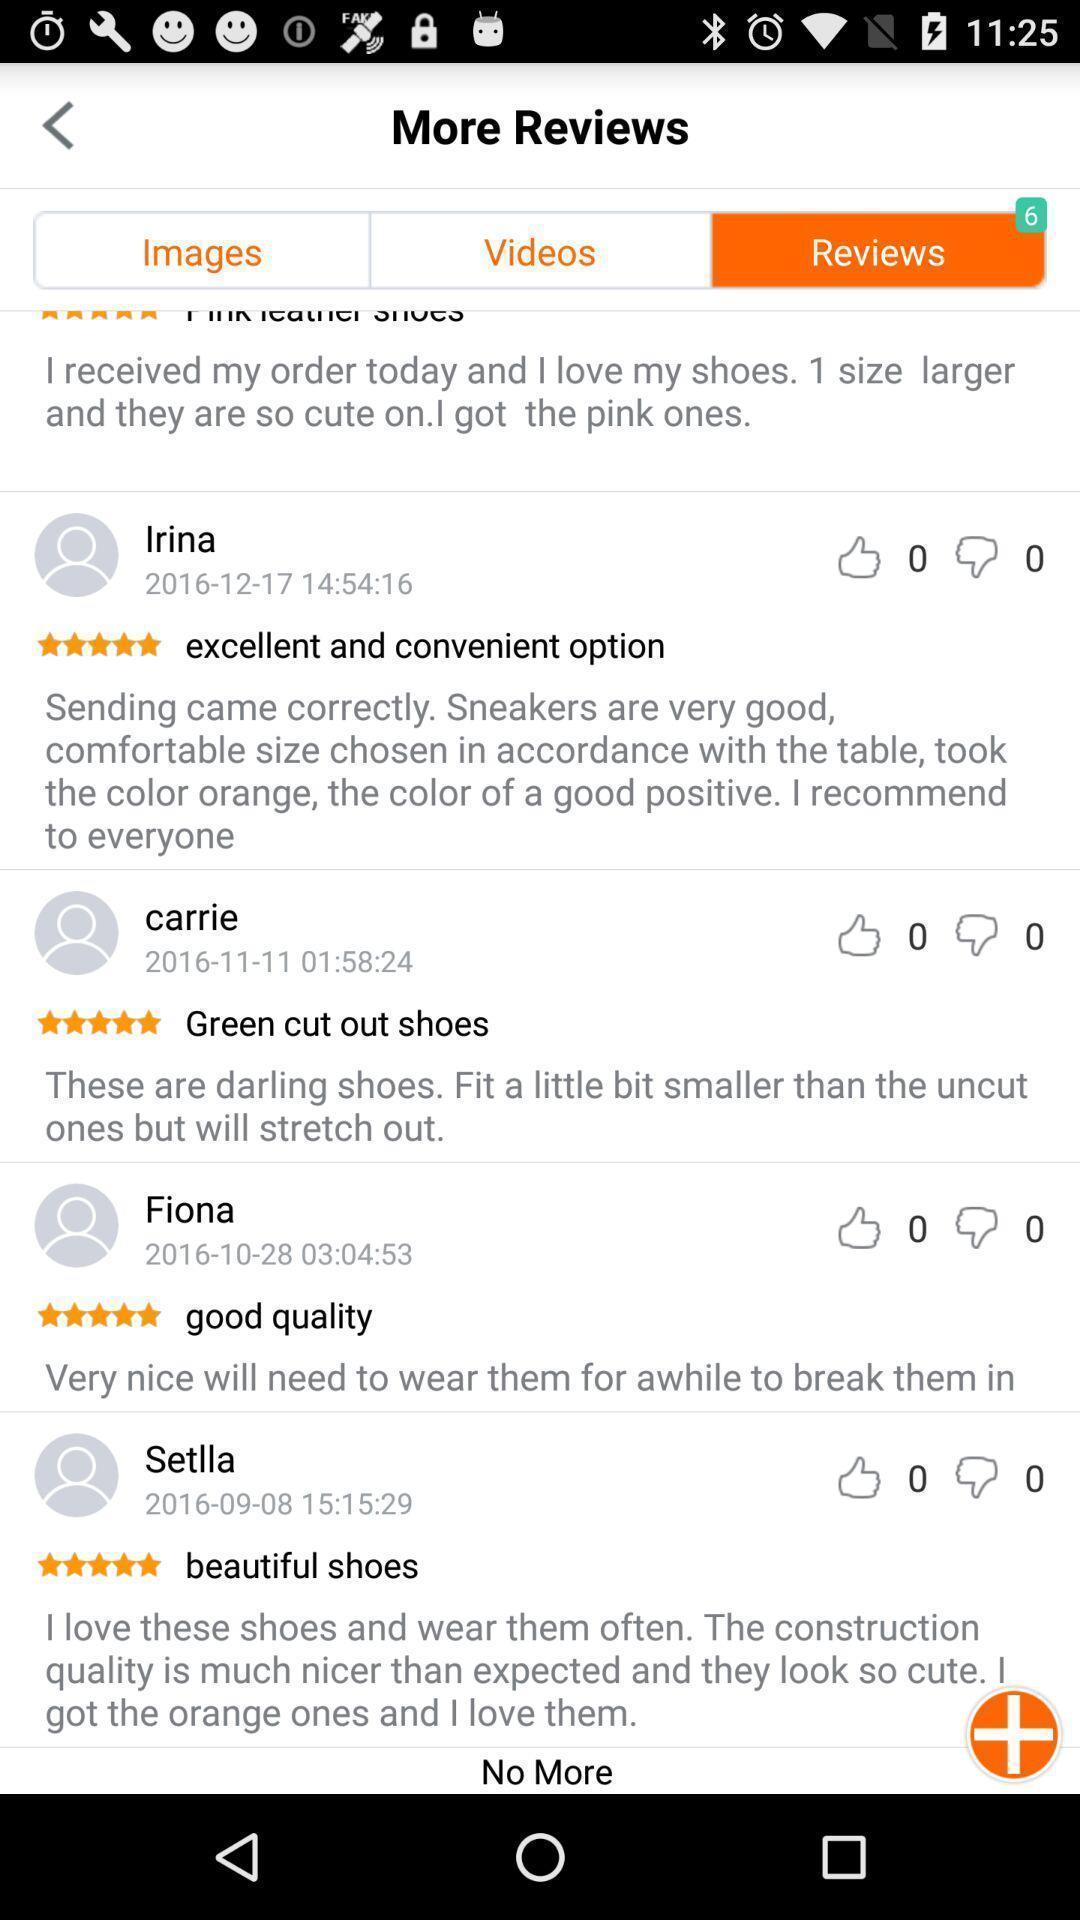Summarize the information in this screenshot. Page showing reviews in an ecommerce app. 